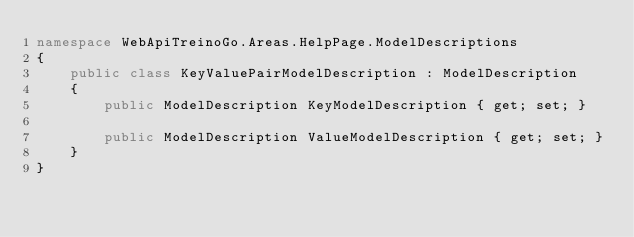<code> <loc_0><loc_0><loc_500><loc_500><_C#_>namespace WebApiTreinoGo.Areas.HelpPage.ModelDescriptions
{
    public class KeyValuePairModelDescription : ModelDescription
    {
        public ModelDescription KeyModelDescription { get; set; }

        public ModelDescription ValueModelDescription { get; set; }
    }
}</code> 